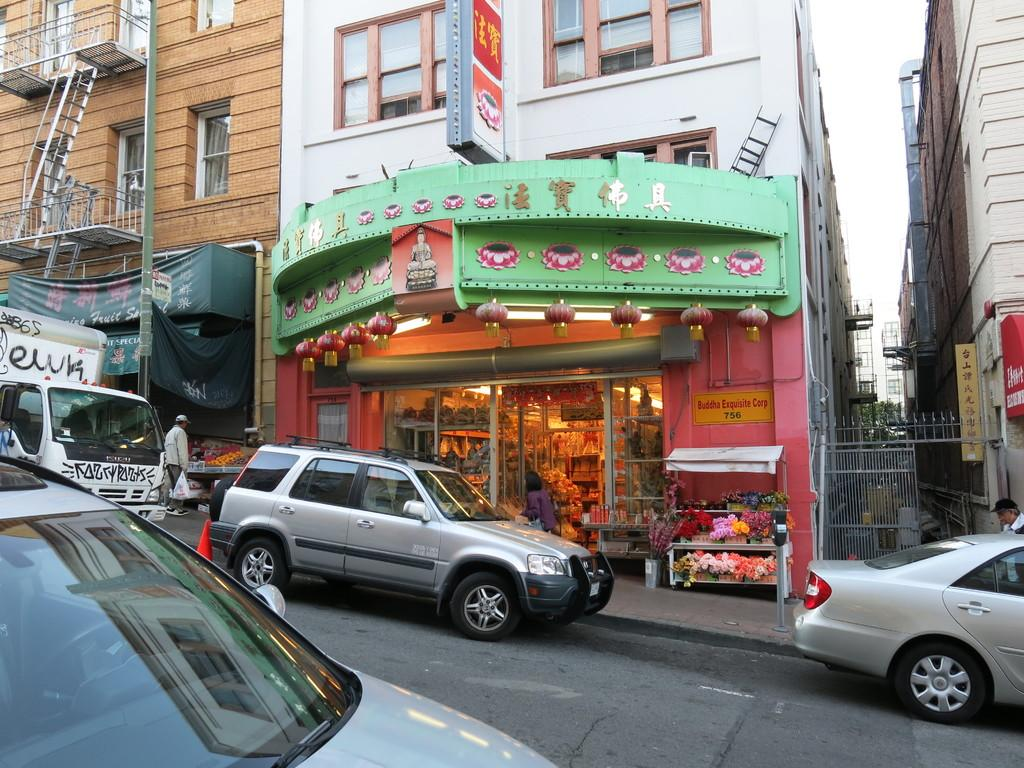What types of man-made structures can be seen in the image? There are buildings in the image. What types of vehicles are present in the image? The image contains vehicles. What types of signs are visible in the image? Name boards and sign boards are visible in the image. What types of decorative items are present in the image? Grills, flower pots in stands, and name boards are present in the image. Are there any living beings in the image? Yes, there are people in the image. What is the primary surface visible in the image? There is a road at the bottom of the image. Can you tell me how many ducks are sitting on the roof of the building in the image? There are no ducks present in the image; it features vehicles, buildings, and people. What type of nut is being used to secure the sign board in the image? There is no mention of nuts being used to secure the sign board in the image; it simply shows sign boards and name boards. 